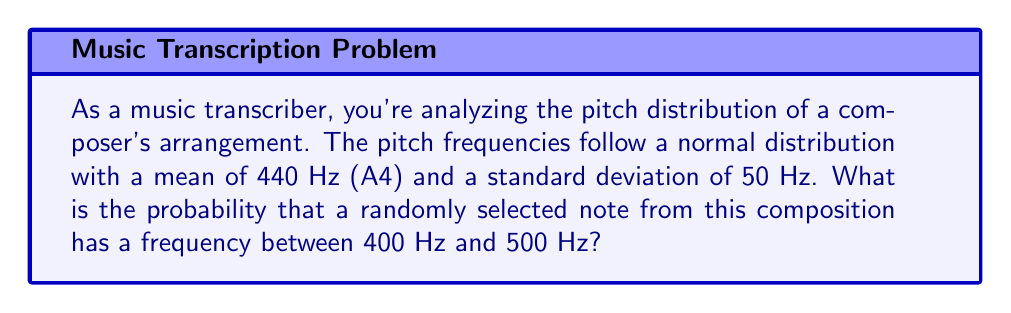Help me with this question. To solve this problem, we'll use the properties of the normal distribution and the concept of standardization:

1) The pitch frequencies follow a normal distribution with:
   $\mu = 440$ Hz
   $\sigma = 50$ Hz

2) We need to find $P(400 < X < 500)$, where $X$ is the frequency of a randomly selected note.

3) Standardize the interval bounds:
   For the lower bound: $z_1 = \frac{400 - 440}{50} = -0.8$
   For the upper bound: $z_2 = \frac{500 - 440}{50} = 1.2$

4) The probability is now $P(-0.8 < Z < 1.2)$, where $Z$ is the standard normal variable.

5) Using the standard normal distribution table or a calculator:
   $P(Z < 1.2) = 0.8849$
   $P(Z < -0.8) = 0.2119$

6) The required probability is:
   $P(-0.8 < Z < 1.2) = P(Z < 1.2) - P(Z < -0.8)$
   $= 0.8849 - 0.2119 = 0.6730$

Therefore, the probability that a randomly selected note has a frequency between 400 Hz and 500 Hz is approximately 0.6730 or 67.30%.
Answer: 0.6730 